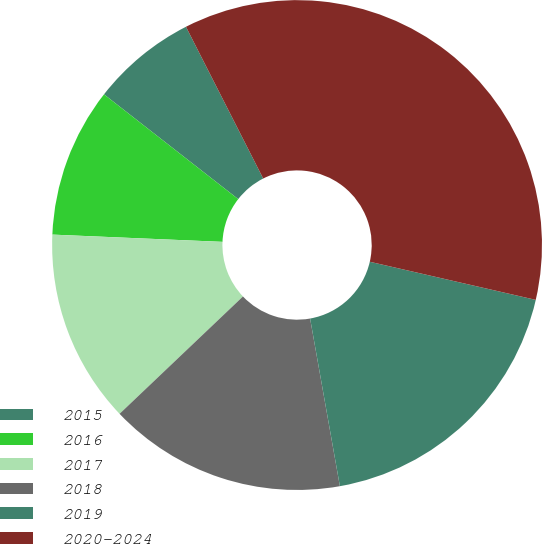<chart> <loc_0><loc_0><loc_500><loc_500><pie_chart><fcel>2015<fcel>2016<fcel>2017<fcel>2018<fcel>2019<fcel>2020-2024<nl><fcel>6.96%<fcel>9.87%<fcel>12.78%<fcel>15.7%<fcel>18.61%<fcel>36.09%<nl></chart> 